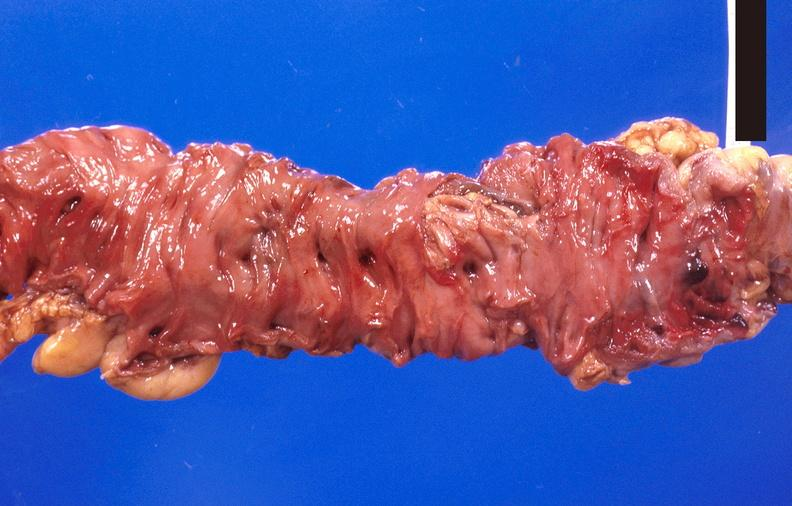does 70yof show colon polyposis?
Answer the question using a single word or phrase. No 